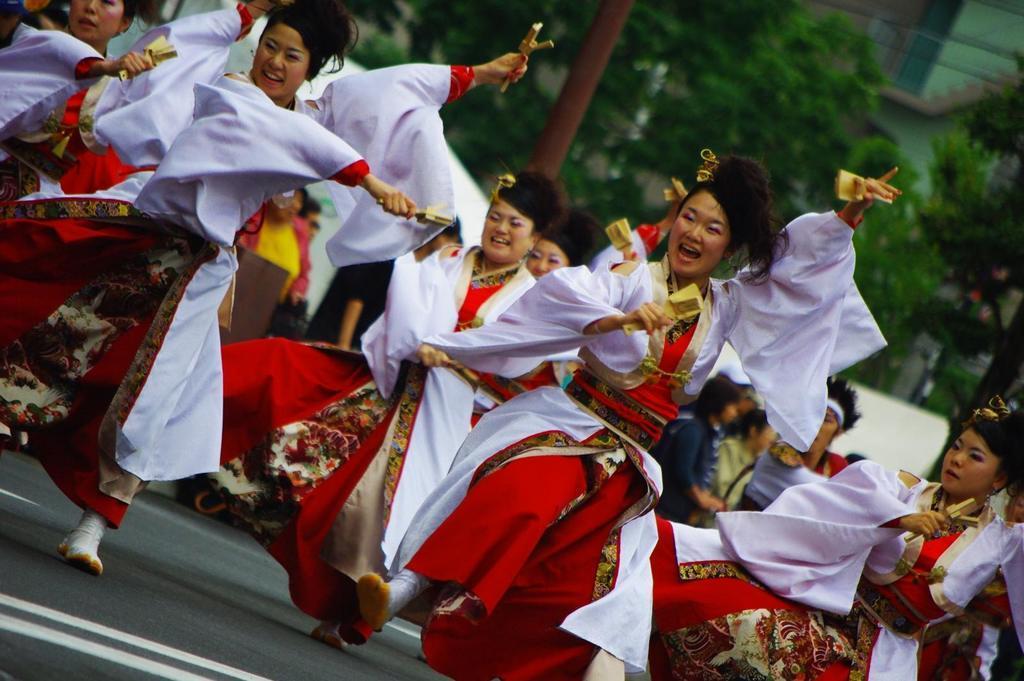Please provide a concise description of this image. In this image we can see some people wearing a colorful dress and holding an object in their hands and we can also see those people are dancing on the road. In the background, we can some trees and a building. 